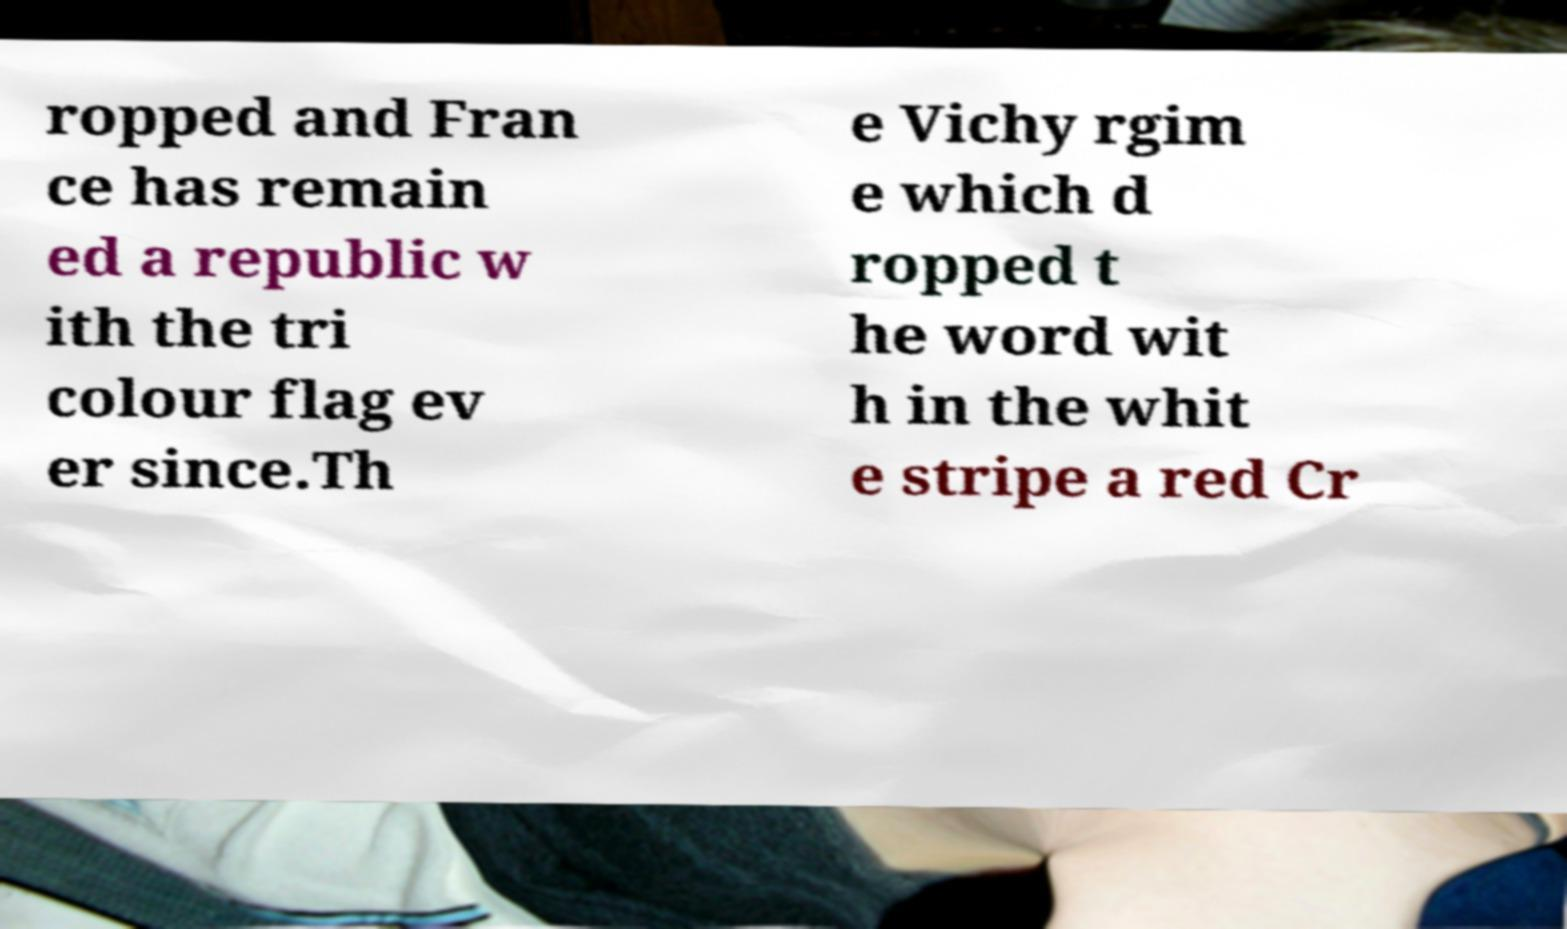There's text embedded in this image that I need extracted. Can you transcribe it verbatim? ropped and Fran ce has remain ed a republic w ith the tri colour flag ev er since.Th e Vichy rgim e which d ropped t he word wit h in the whit e stripe a red Cr 